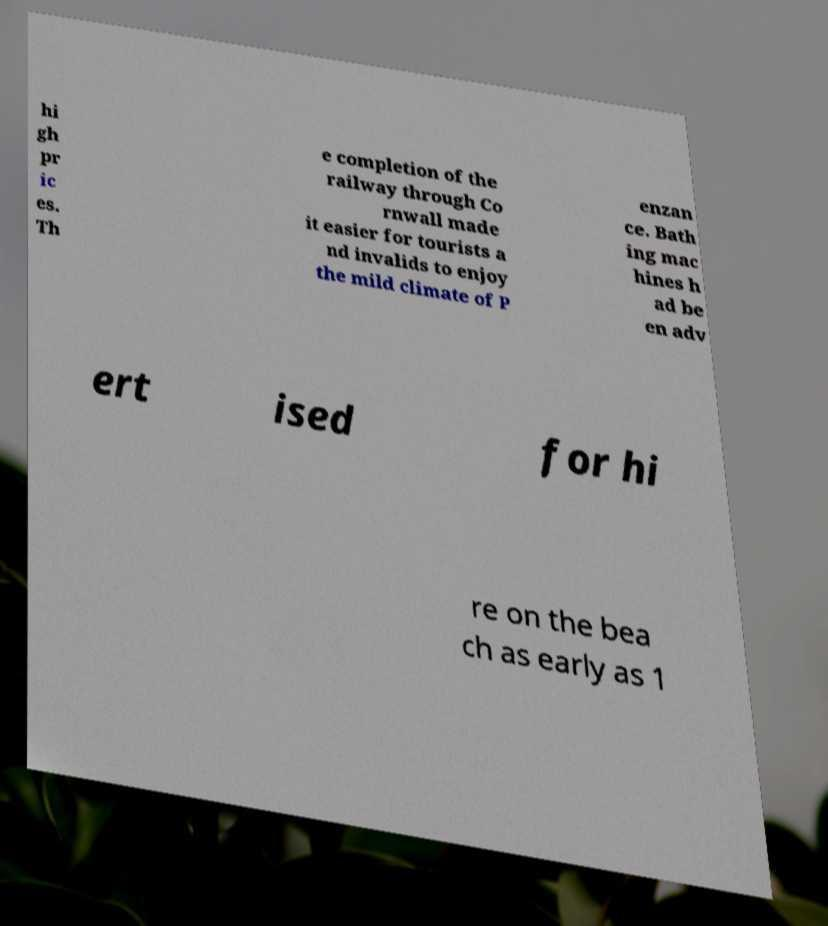Can you accurately transcribe the text from the provided image for me? hi gh pr ic es. Th e completion of the railway through Co rnwall made it easier for tourists a nd invalids to enjoy the mild climate of P enzan ce. Bath ing mac hines h ad be en adv ert ised for hi re on the bea ch as early as 1 